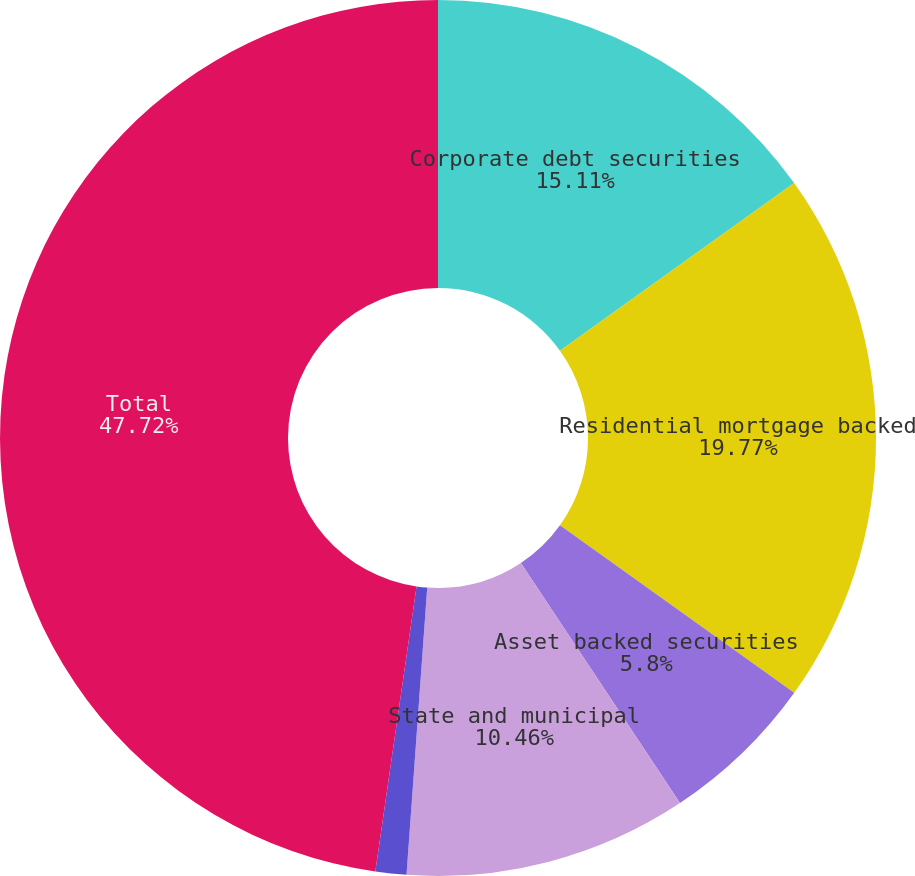Convert chart to OTSL. <chart><loc_0><loc_0><loc_500><loc_500><pie_chart><fcel>Corporate debt securities<fcel>Residential mortgage backed<fcel>Asset backed securities<fcel>State and municipal<fcel>Foreign government bonds and<fcel>Total<nl><fcel>15.11%<fcel>19.77%<fcel>5.8%<fcel>10.46%<fcel>1.14%<fcel>47.71%<nl></chart> 